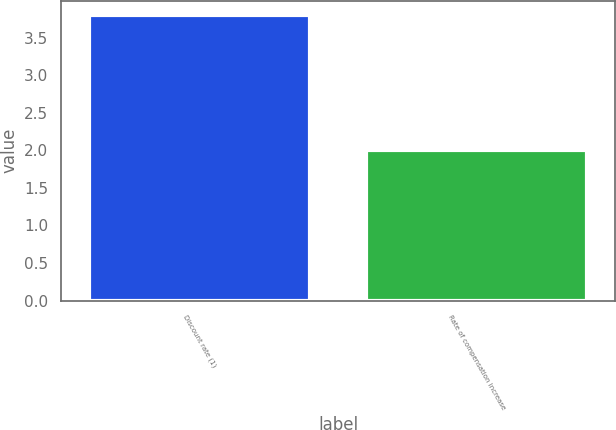Convert chart to OTSL. <chart><loc_0><loc_0><loc_500><loc_500><bar_chart><fcel>Discount rate (1)<fcel>Rate of compensation increase<nl><fcel>3.8<fcel>2<nl></chart> 